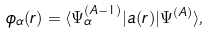Convert formula to latex. <formula><loc_0><loc_0><loc_500><loc_500>\phi _ { \alpha } ( { r } ) = \langle \Psi ^ { ( A - 1 ) } _ { \alpha } | a ( { r } ) | \Psi ^ { ( A ) } \rangle ,</formula> 